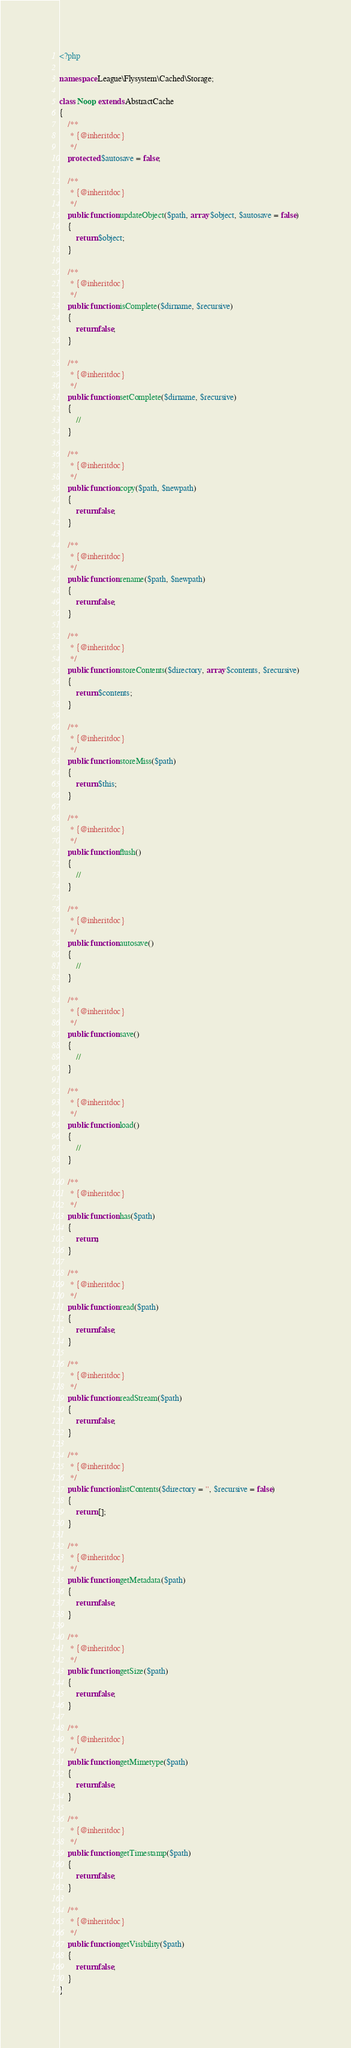<code> <loc_0><loc_0><loc_500><loc_500><_PHP_><?php

namespace League\Flysystem\Cached\Storage;

class Noop extends AbstractCache
{
    /**
     * {@inheritdoc}
     */
    protected $autosave = false;

    /**
     * {@inheritdoc}
     */
    public function updateObject($path, array $object, $autosave = false)
    {
        return $object;
    }

    /**
     * {@inheritdoc}
     */
    public function isComplete($dirname, $recursive)
    {
        return false;
    }

    /**
     * {@inheritdoc}
     */
    public function setComplete($dirname, $recursive)
    {
        //
    }

    /**
     * {@inheritdoc}
     */
    public function copy($path, $newpath)
    {
        return false;
    }

    /**
     * {@inheritdoc}
     */
    public function rename($path, $newpath)
    {
        return false;
    }

    /**
     * {@inheritdoc}
     */
    public function storeContents($directory, array $contents, $recursive)
    {
        return $contents;
    }

    /**
     * {@inheritdoc}
     */
    public function storeMiss($path)
    {
        return $this;
    }

    /**
     * {@inheritdoc}
     */
    public function flush()
    {
        //
    }

    /**
     * {@inheritdoc}
     */
    public function autosave()
    {
        //
    }

    /**
     * {@inheritdoc}
     */
    public function save()
    {
        //
    }

    /**
     * {@inheritdoc}
     */
    public function load()
    {
        //
    }

    /**
     * {@inheritdoc}
     */
    public function has($path)
    {
        return;
    }

    /**
     * {@inheritdoc}
     */
    public function read($path)
    {
        return false;
    }

    /**
     * {@inheritdoc}
     */
    public function readStream($path)
    {
        return false;
    }

    /**
     * {@inheritdoc}
     */
    public function listContents($directory = '', $recursive = false)
    {
        return [];
    }

    /**
     * {@inheritdoc}
     */
    public function getMetadata($path)
    {
        return false;
    }

    /**
     * {@inheritdoc}
     */
    public function getSize($path)
    {
        return false;
    }

    /**
     * {@inheritdoc}
     */
    public function getMimetype($path)
    {
        return false;
    }

    /**
     * {@inheritdoc}
     */
    public function getTimestamp($path)
    {
        return false;
    }

    /**
     * {@inheritdoc}
     */
    public function getVisibility($path)
    {
        return false;
    }
}
</code> 